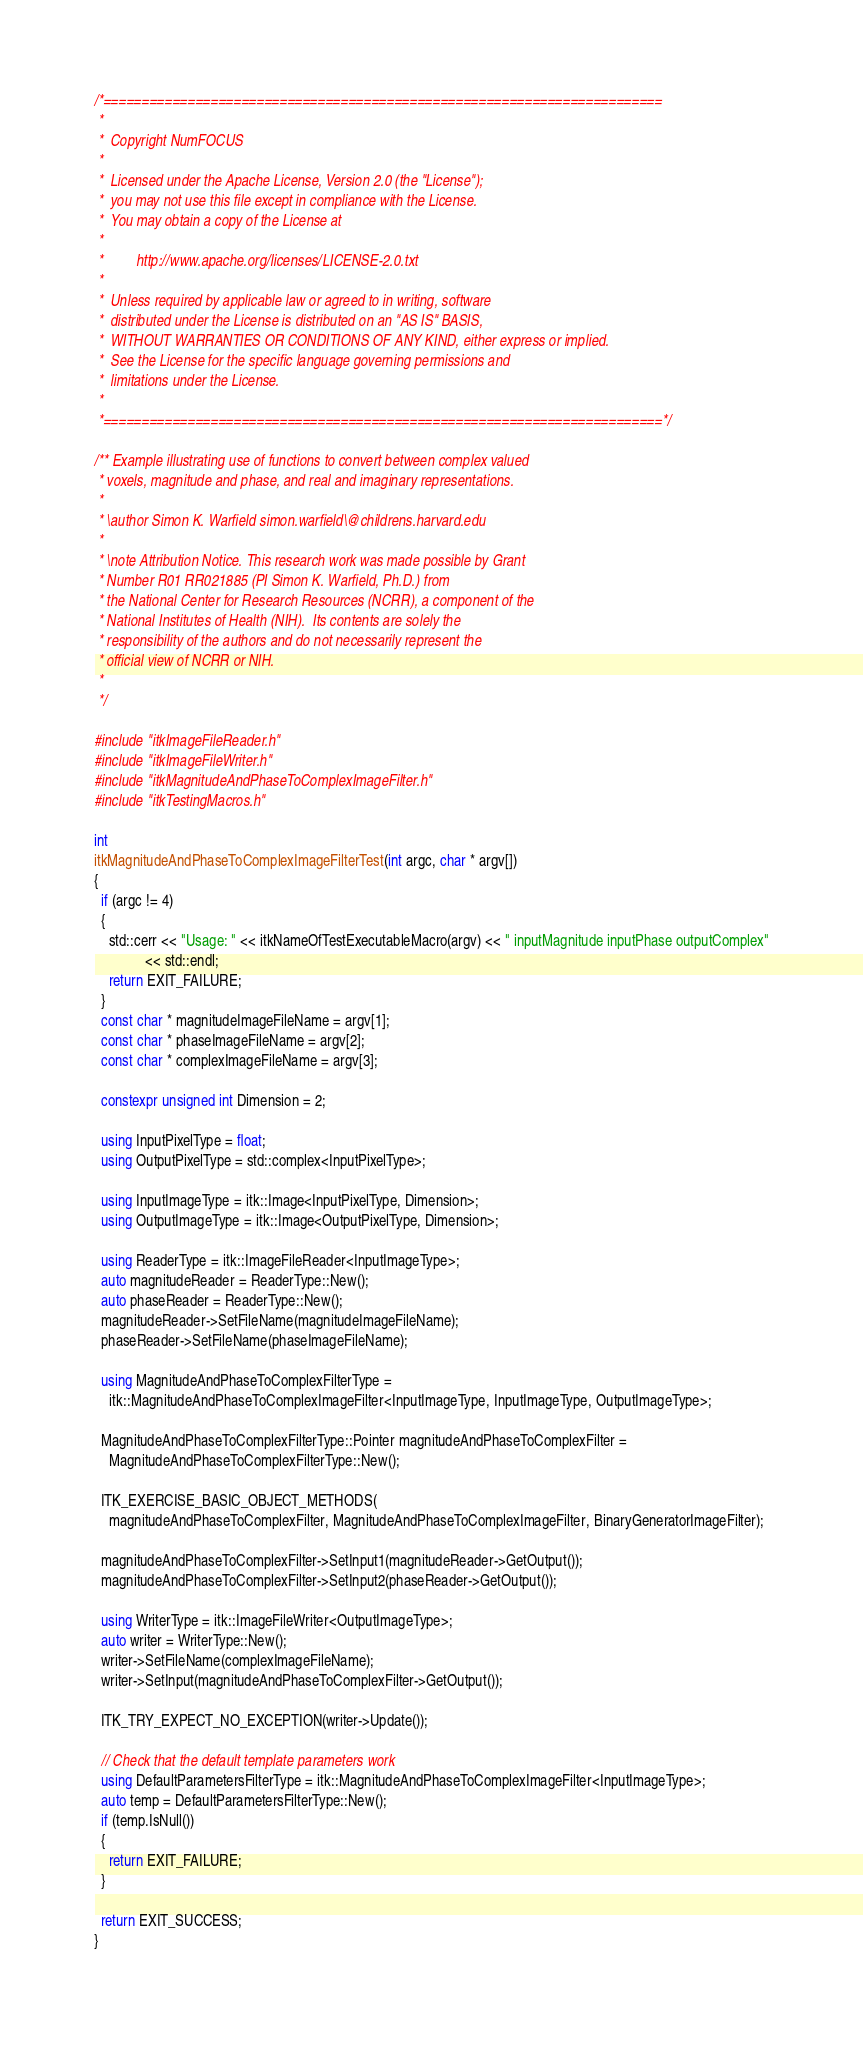<code> <loc_0><loc_0><loc_500><loc_500><_C++_>/*=========================================================================
 *
 *  Copyright NumFOCUS
 *
 *  Licensed under the Apache License, Version 2.0 (the "License");
 *  you may not use this file except in compliance with the License.
 *  You may obtain a copy of the License at
 *
 *         http://www.apache.org/licenses/LICENSE-2.0.txt
 *
 *  Unless required by applicable law or agreed to in writing, software
 *  distributed under the License is distributed on an "AS IS" BASIS,
 *  WITHOUT WARRANTIES OR CONDITIONS OF ANY KIND, either express or implied.
 *  See the License for the specific language governing permissions and
 *  limitations under the License.
 *
 *=========================================================================*/

/** Example illustrating use of functions to convert between complex valued
 * voxels, magnitude and phase, and real and imaginary representations.
 *
 * \author Simon K. Warfield simon.warfield\@childrens.harvard.edu
 *
 * \note Attribution Notice. This research work was made possible by Grant
 * Number R01 RR021885 (PI Simon K. Warfield, Ph.D.) from
 * the National Center for Research Resources (NCRR), a component of the
 * National Institutes of Health (NIH).  Its contents are solely the
 * responsibility of the authors and do not necessarily represent the
 * official view of NCRR or NIH.
 *
 */

#include "itkImageFileReader.h"
#include "itkImageFileWriter.h"
#include "itkMagnitudeAndPhaseToComplexImageFilter.h"
#include "itkTestingMacros.h"

int
itkMagnitudeAndPhaseToComplexImageFilterTest(int argc, char * argv[])
{
  if (argc != 4)
  {
    std::cerr << "Usage: " << itkNameOfTestExecutableMacro(argv) << " inputMagnitude inputPhase outputComplex"
              << std::endl;
    return EXIT_FAILURE;
  }
  const char * magnitudeImageFileName = argv[1];
  const char * phaseImageFileName = argv[2];
  const char * complexImageFileName = argv[3];

  constexpr unsigned int Dimension = 2;

  using InputPixelType = float;
  using OutputPixelType = std::complex<InputPixelType>;

  using InputImageType = itk::Image<InputPixelType, Dimension>;
  using OutputImageType = itk::Image<OutputPixelType, Dimension>;

  using ReaderType = itk::ImageFileReader<InputImageType>;
  auto magnitudeReader = ReaderType::New();
  auto phaseReader = ReaderType::New();
  magnitudeReader->SetFileName(magnitudeImageFileName);
  phaseReader->SetFileName(phaseImageFileName);

  using MagnitudeAndPhaseToComplexFilterType =
    itk::MagnitudeAndPhaseToComplexImageFilter<InputImageType, InputImageType, OutputImageType>;

  MagnitudeAndPhaseToComplexFilterType::Pointer magnitudeAndPhaseToComplexFilter =
    MagnitudeAndPhaseToComplexFilterType::New();

  ITK_EXERCISE_BASIC_OBJECT_METHODS(
    magnitudeAndPhaseToComplexFilter, MagnitudeAndPhaseToComplexImageFilter, BinaryGeneratorImageFilter);

  magnitudeAndPhaseToComplexFilter->SetInput1(magnitudeReader->GetOutput());
  magnitudeAndPhaseToComplexFilter->SetInput2(phaseReader->GetOutput());

  using WriterType = itk::ImageFileWriter<OutputImageType>;
  auto writer = WriterType::New();
  writer->SetFileName(complexImageFileName);
  writer->SetInput(magnitudeAndPhaseToComplexFilter->GetOutput());

  ITK_TRY_EXPECT_NO_EXCEPTION(writer->Update());

  // Check that the default template parameters work
  using DefaultParametersFilterType = itk::MagnitudeAndPhaseToComplexImageFilter<InputImageType>;
  auto temp = DefaultParametersFilterType::New();
  if (temp.IsNull())
  {
    return EXIT_FAILURE;
  }

  return EXIT_SUCCESS;
}
</code> 